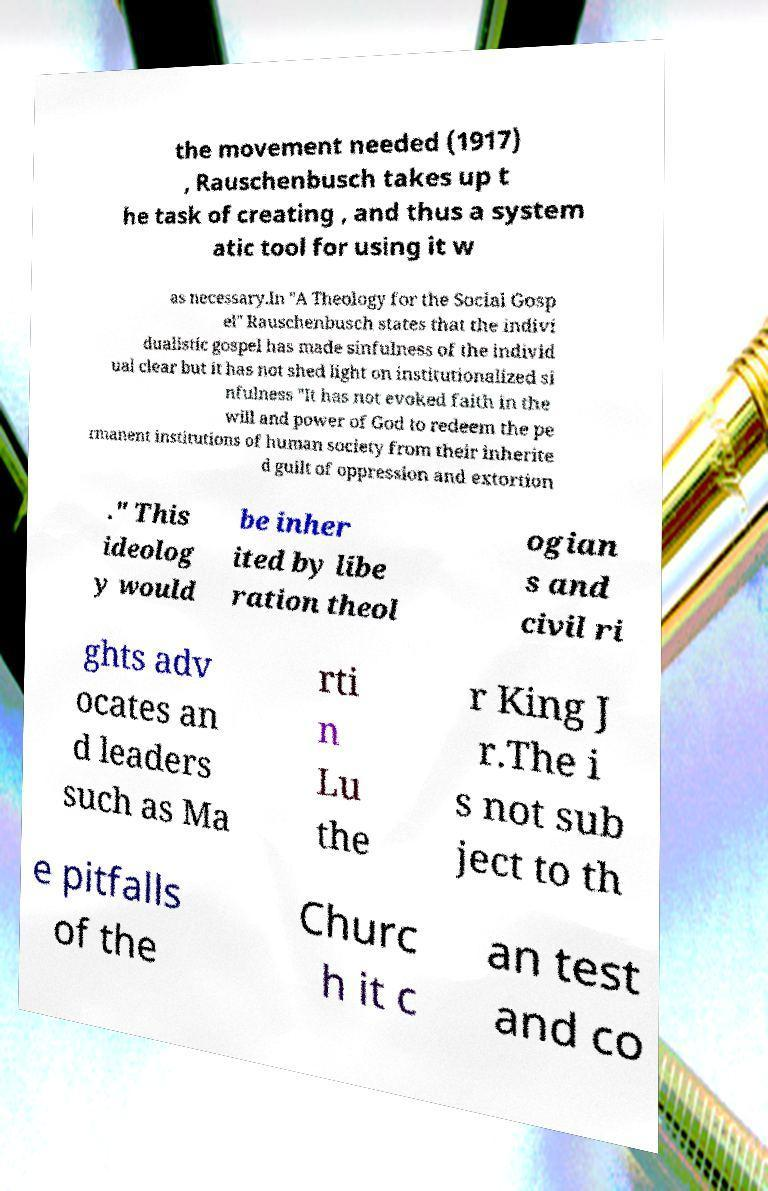Can you read and provide the text displayed in the image?This photo seems to have some interesting text. Can you extract and type it out for me? the movement needed (1917) , Rauschenbusch takes up t he task of creating , and thus a system atic tool for using it w as necessary.In "A Theology for the Social Gosp el" Rauschenbusch states that the indivi dualistic gospel has made sinfulness of the individ ual clear but it has not shed light on institutionalized si nfulness "It has not evoked faith in the will and power of God to redeem the pe rmanent institutions of human society from their inherite d guilt of oppression and extortion ." This ideolog y would be inher ited by libe ration theol ogian s and civil ri ghts adv ocates an d leaders such as Ma rti n Lu the r King J r.The i s not sub ject to th e pitfalls of the Churc h it c an test and co 